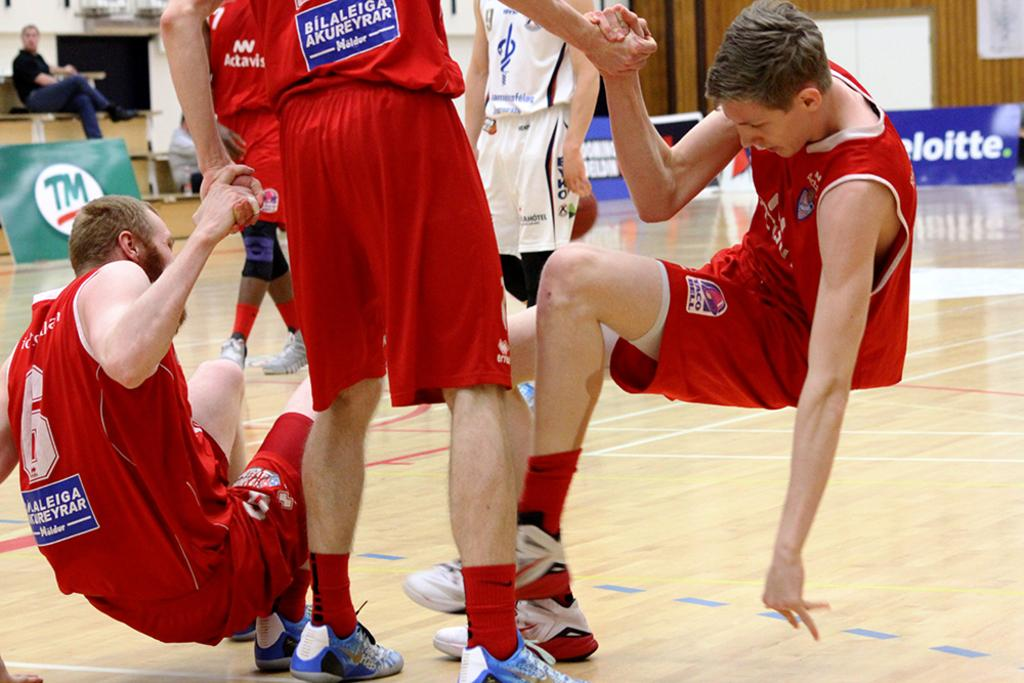<image>
Describe the image concisely. Three guys on a basketball court with the word Yrar on the back of their shirt. 